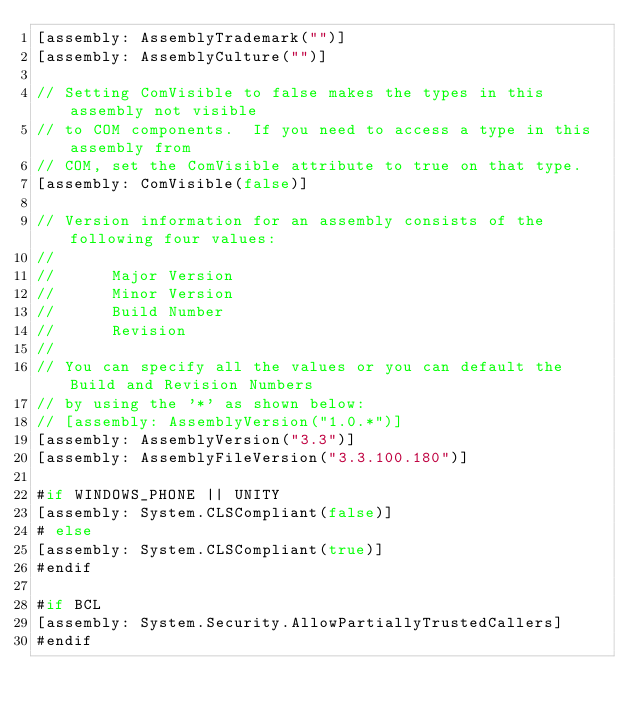<code> <loc_0><loc_0><loc_500><loc_500><_C#_>[assembly: AssemblyTrademark("")]
[assembly: AssemblyCulture("")]

// Setting ComVisible to false makes the types in this assembly not visible 
// to COM components.  If you need to access a type in this assembly from 
// COM, set the ComVisible attribute to true on that type.
[assembly: ComVisible(false)]

// Version information for an assembly consists of the following four values:
//
//      Major Version
//      Minor Version 
//      Build Number
//      Revision
//
// You can specify all the values or you can default the Build and Revision Numbers 
// by using the '*' as shown below:
// [assembly: AssemblyVersion("1.0.*")]
[assembly: AssemblyVersion("3.3")]
[assembly: AssemblyFileVersion("3.3.100.180")]

#if WINDOWS_PHONE || UNITY
[assembly: System.CLSCompliant(false)]
# else
[assembly: System.CLSCompliant(true)]
#endif

#if BCL
[assembly: System.Security.AllowPartiallyTrustedCallers]
#endif</code> 